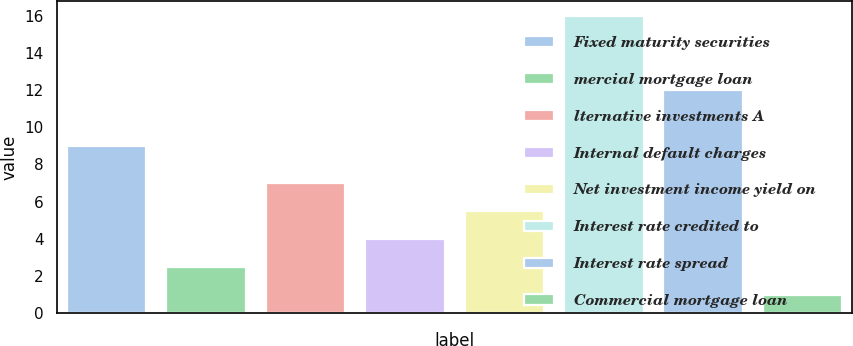Convert chart. <chart><loc_0><loc_0><loc_500><loc_500><bar_chart><fcel>Fixed maturity securities<fcel>mercial mortgage loan<fcel>lternative investments A<fcel>Internal default charges<fcel>Net investment income yield on<fcel>Interest rate credited to<fcel>Interest rate spread<fcel>Commercial mortgage loan<nl><fcel>9<fcel>2.5<fcel>7<fcel>4<fcel>5.5<fcel>16<fcel>12<fcel>1<nl></chart> 